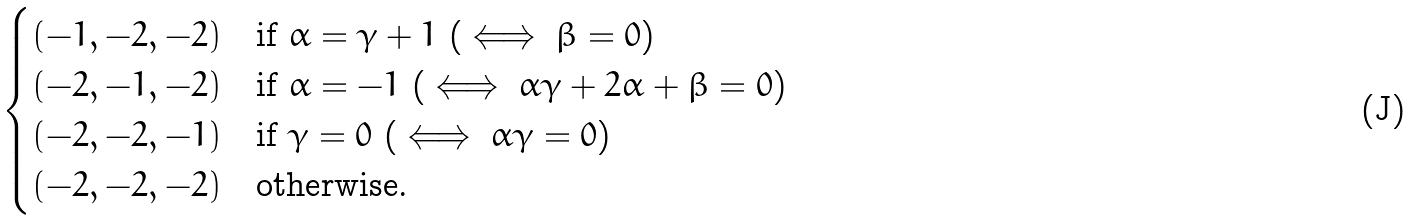Convert formula to latex. <formula><loc_0><loc_0><loc_500><loc_500>\begin{cases} ( - 1 , - 2 , - 2 ) & \text {if $\alpha=\gamma+1$ ($ \iff \beta=0$)} \\ ( - 2 , - 1 , - 2 ) & \text {if $\alpha=-1$ ($\iff \alpha\gamma+2\alpha+\beta=0$)} \\ ( - 2 , - 2 , - 1 ) & \text {if $\gamma=0$ ($\iff \alpha\gamma=0$)} \\ ( - 2 , - 2 , - 2 ) & \text {otherwise.} \end{cases}</formula> 